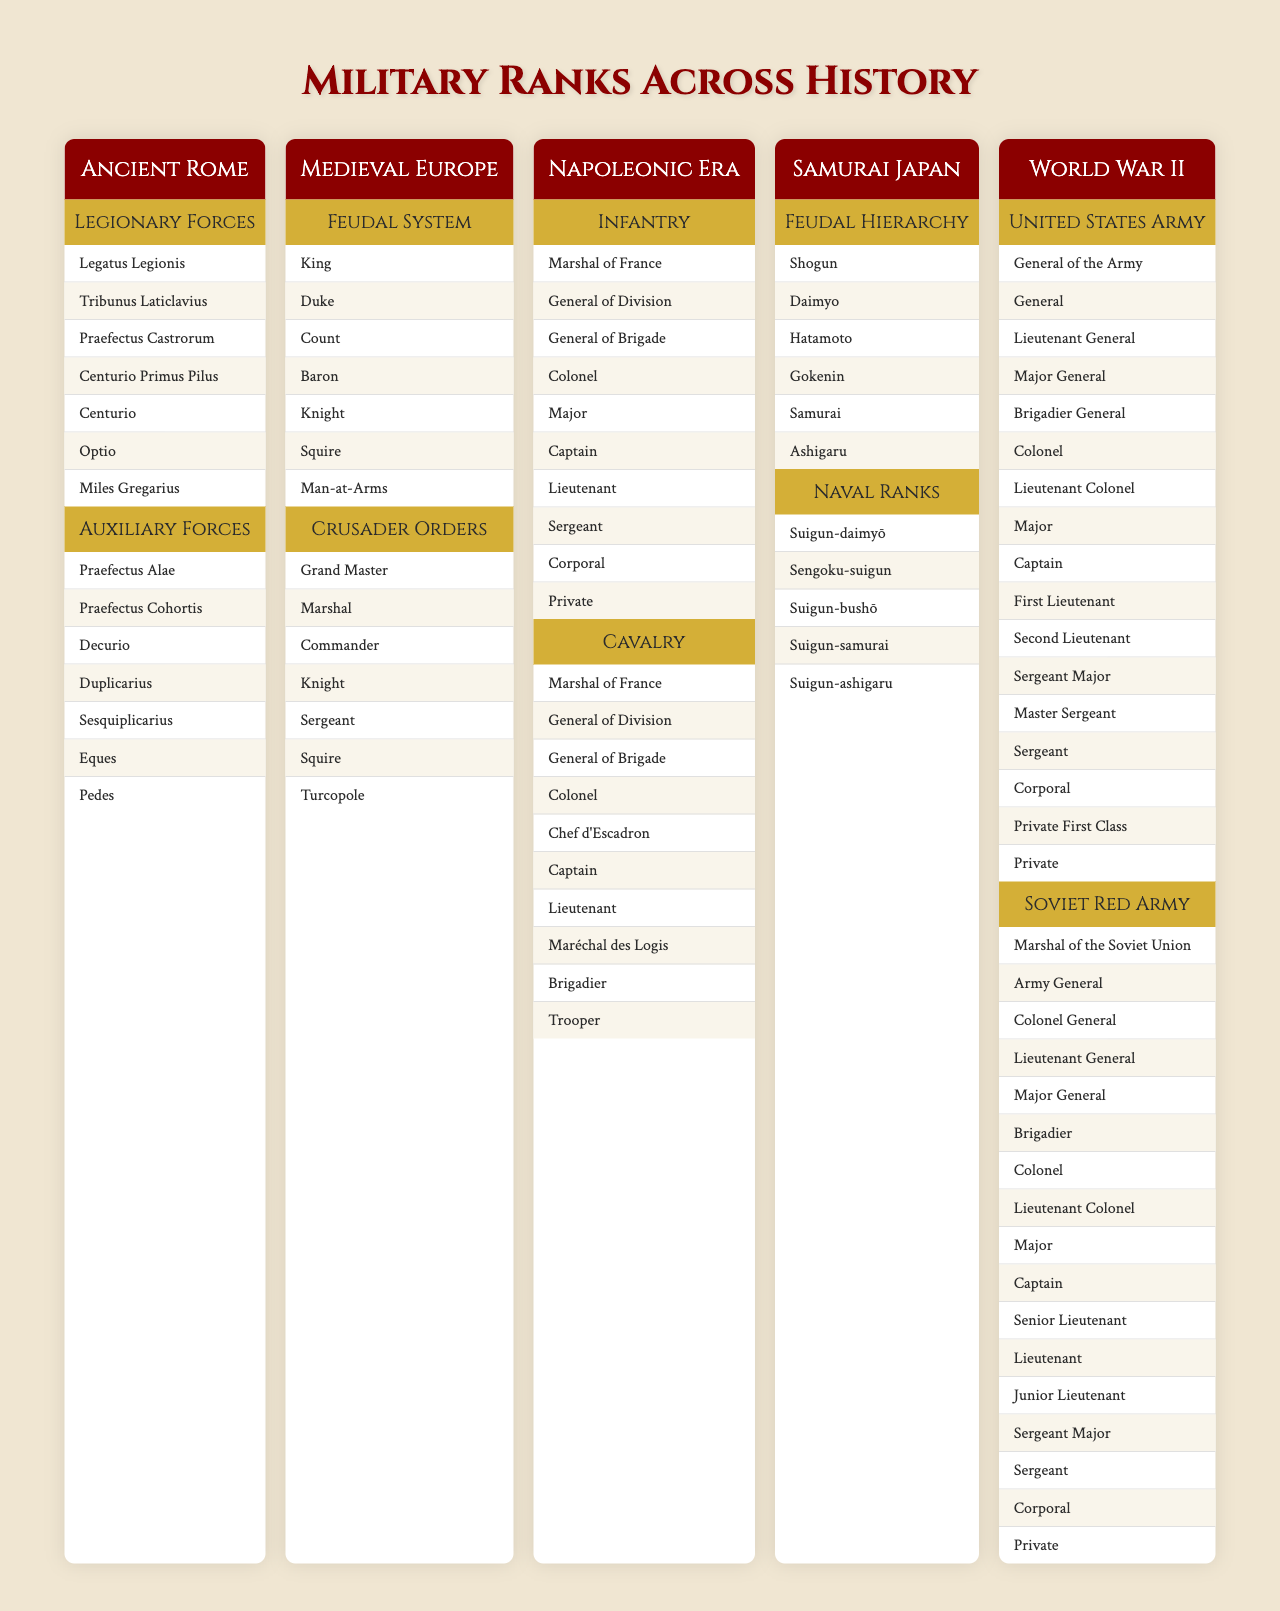What is the highest rank in Ancient Rome's Legionary Forces? The highest rank listed under the Legionary Forces is "Legatus Legionis," which is the commander of a legion.
Answer: Legatus Legionis How many ranks are there in the Medieval European Feudal System? The Feudal System has 7 ranks listed: King, Duke, Count, Baron, Knight, Squire, and Man-at-Arms.
Answer: 7 Are there more ranks in the Napoleonic Era Infantry than in its Cavalry? Both the Infantry and Cavalry of the Napoleonic Era have the same number of ranks listed, which is 10 for each.
Answer: No What is the rank just below "General of Brigade" in the Napoleonic Era Infantry? The rank directly below "General of Brigade" in the Infantry is "Colonel."
Answer: Colonel Which military system has a rank of "Grand Master"? The rank "Grand Master" appears in the Crusader Orders within Medieval Europe.
Answer: Crusader Orders In Samurai Japan, how many ranks are listed under Naval Ranks? There are 5 ranks listed under Naval Ranks: Suigun-daimyō, Sengoku-suigun, Suigun-bushō, Suigun-samurai, and Suigun-ashigaru.
Answer: 5 Which has a higher military rank: "General" in the United States Army or "Colonel" in the Soviet Red Army? "General" in the United States Army is a higher rank than "Colonel" in the Soviet Red Army, as "Colonel" is below "General" by one rank.
Answer: General How many total ranks are listed for the United States Army in World War II? There are 16 ranks listed for the United States Army in World War II. These include General of the Army, General, and so on down to Private.
Answer: 16 Is "Shogun" the highest rank in Samurai Japan? Yes, "Shogun" is indeed recognized as the highest military rank in Samurai Japan.
Answer: Yes List all ranks under the Auxiliary Forces of Ancient Rome. The ranks under the Auxiliary Forces are: Praefectus Alae, Praefectus Cohortis, Decurio, Duplicarius, Sesquiplicarius, Eques, and Pedes.
Answer: Praefectus Alae, Praefectus Cohortis, Decurio, Duplicarius, Sesquiplicarius, Eques, Pedes Which historical period includes the rank "Marshall"? The rank "Marshal" is included in both the Napoleonic Era for Infantry and Cavalry.
Answer: Napoleonic Era What is the total number of ranks mentioned across Samurai Japan's Feudal Hierarchy and Naval Ranks? There are 6 ranks in Feudal Hierarchy and 5 in Naval Ranks, totaling 11 ranks in Samurai Japan.
Answer: 11 How many ranks have the title "Knight" across all historical periods presented? The title "Knight" appears in Medieval Europe (once in Feudal System and once in Crusader Orders), totaling 2 occurrences.
Answer: 2 Which has more ranks, World War II's Soviet Red Army or Ancient Rome's Legionary Forces? The Soviet Red Army has 16 ranks listing, while Ancient Rome's Legionary Forces has 7 ranks, so the Soviet Red Army has more ranks.
Answer: Soviet Red Army 